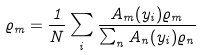<formula> <loc_0><loc_0><loc_500><loc_500>\varrho _ { m } = \frac { 1 } { N } \sum _ { i } \frac { A _ { m } ( y _ { i } ) \varrho _ { m } } { \sum _ { n } A _ { n } ( y _ { i } ) \varrho _ { n } }</formula> 